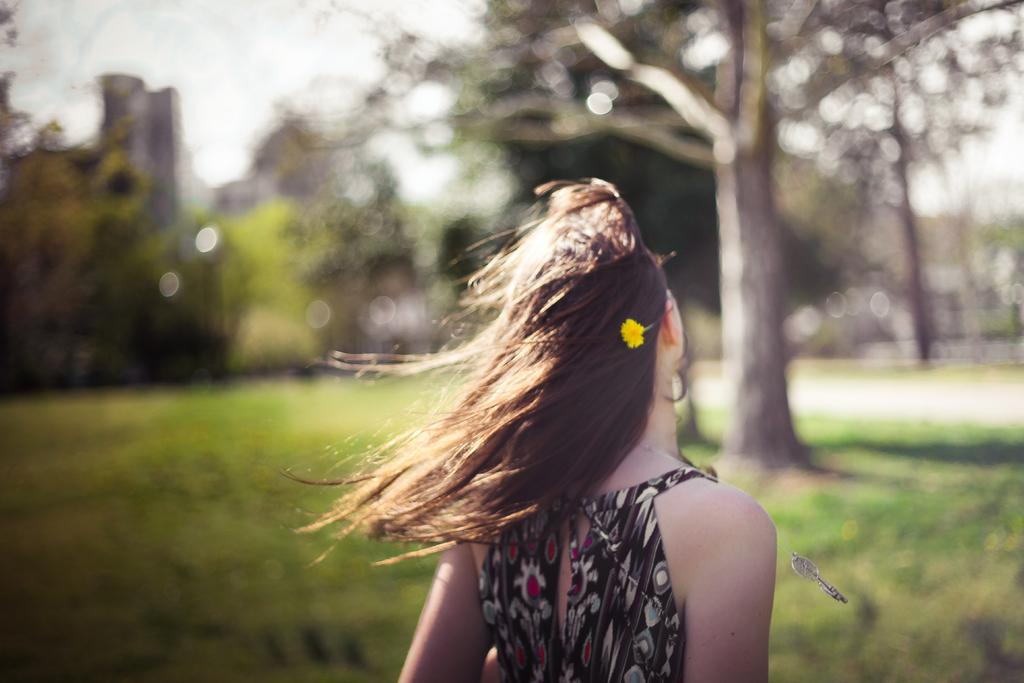Who is the main subject in the image? There is a lady in the image. What can be seen in the background of the image? There are trees, buildings, and the sky visible in the background of the image. What type of terrain is at the bottom of the image? There is grass at the bottom of the image. How many crows are sitting on the lady's shoulder in the image? There are no crows present in the image. What type of addition problem can be solved using the lady's hat in the image? There is no addition problem or hat visible in the image. 